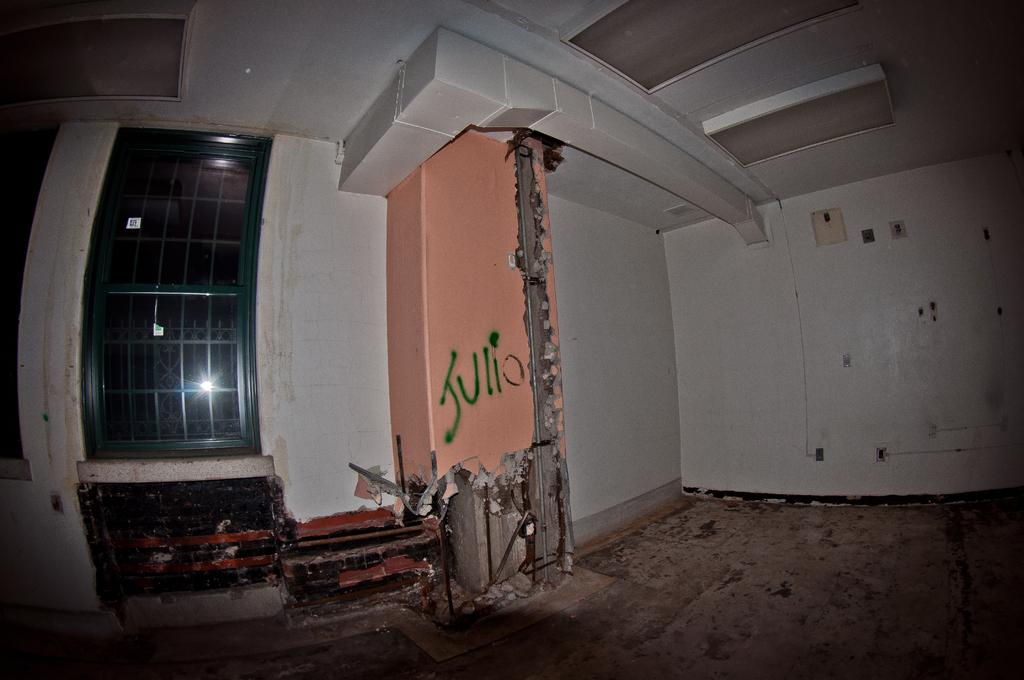What is located in the center of the image? There is a wall and a window in the center of the image. What can be seen through the window in the image? The image does not show what can be seen through the window. What is on the wall in the image? There is text on the wall in the image. Are there any objects visible in the center of the image? Yes, there are objects in the center of the image. What type of dirt can be seen on the playground in the image? There is no playground present in the image, so it is not possible to determine what type of dirt might be on it. 